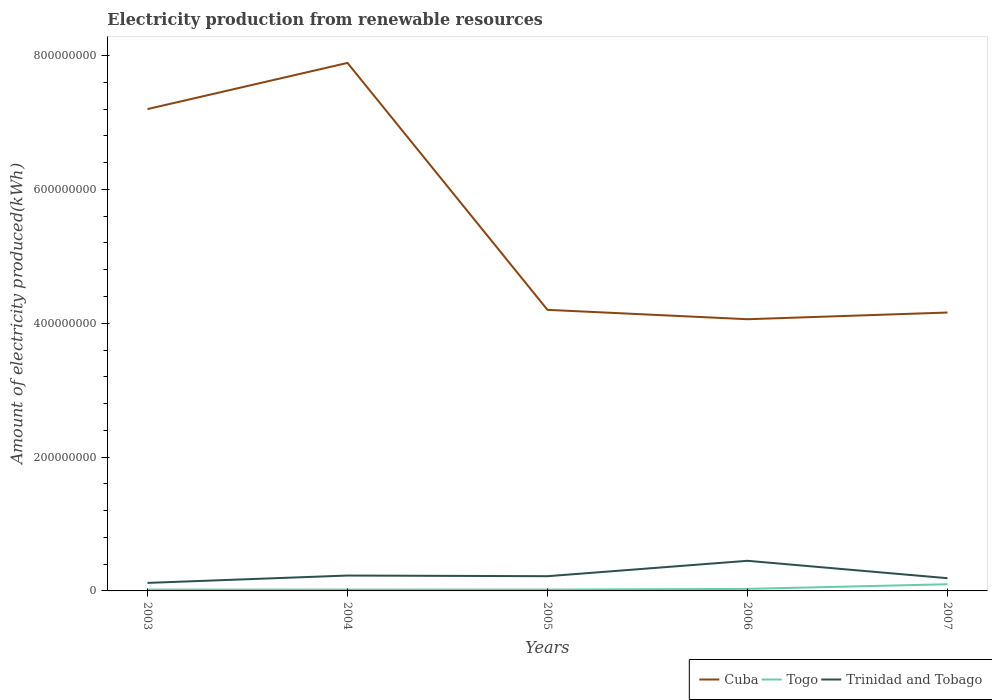How many different coloured lines are there?
Your answer should be very brief. 3. Is the number of lines equal to the number of legend labels?
Your answer should be very brief. Yes. Across all years, what is the maximum amount of electricity produced in Togo?
Give a very brief answer. 2.00e+06. In which year was the amount of electricity produced in Togo maximum?
Offer a very short reply. 2003. What is the total amount of electricity produced in Trinidad and Tobago in the graph?
Offer a very short reply. -3.30e+07. What is the difference between the highest and the second highest amount of electricity produced in Trinidad and Tobago?
Ensure brevity in your answer.  3.30e+07. What is the difference between the highest and the lowest amount of electricity produced in Togo?
Keep it short and to the point. 1. Is the amount of electricity produced in Cuba strictly greater than the amount of electricity produced in Togo over the years?
Keep it short and to the point. No. Does the graph contain any zero values?
Your response must be concise. No. Does the graph contain grids?
Give a very brief answer. No. Where does the legend appear in the graph?
Your answer should be compact. Bottom right. How many legend labels are there?
Your answer should be very brief. 3. What is the title of the graph?
Ensure brevity in your answer.  Electricity production from renewable resources. What is the label or title of the X-axis?
Your response must be concise. Years. What is the label or title of the Y-axis?
Keep it short and to the point. Amount of electricity produced(kWh). What is the Amount of electricity produced(kWh) of Cuba in 2003?
Keep it short and to the point. 7.20e+08. What is the Amount of electricity produced(kWh) in Togo in 2003?
Your response must be concise. 2.00e+06. What is the Amount of electricity produced(kWh) in Cuba in 2004?
Your answer should be very brief. 7.89e+08. What is the Amount of electricity produced(kWh) of Togo in 2004?
Your answer should be compact. 2.00e+06. What is the Amount of electricity produced(kWh) in Trinidad and Tobago in 2004?
Your answer should be compact. 2.30e+07. What is the Amount of electricity produced(kWh) of Cuba in 2005?
Provide a short and direct response. 4.20e+08. What is the Amount of electricity produced(kWh) of Togo in 2005?
Offer a terse response. 2.00e+06. What is the Amount of electricity produced(kWh) in Trinidad and Tobago in 2005?
Keep it short and to the point. 2.20e+07. What is the Amount of electricity produced(kWh) of Cuba in 2006?
Your response must be concise. 4.06e+08. What is the Amount of electricity produced(kWh) in Trinidad and Tobago in 2006?
Your response must be concise. 4.50e+07. What is the Amount of electricity produced(kWh) in Cuba in 2007?
Provide a succinct answer. 4.16e+08. What is the Amount of electricity produced(kWh) of Togo in 2007?
Offer a terse response. 1.00e+07. What is the Amount of electricity produced(kWh) of Trinidad and Tobago in 2007?
Offer a terse response. 1.90e+07. Across all years, what is the maximum Amount of electricity produced(kWh) in Cuba?
Make the answer very short. 7.89e+08. Across all years, what is the maximum Amount of electricity produced(kWh) of Togo?
Keep it short and to the point. 1.00e+07. Across all years, what is the maximum Amount of electricity produced(kWh) of Trinidad and Tobago?
Your answer should be compact. 4.50e+07. Across all years, what is the minimum Amount of electricity produced(kWh) in Cuba?
Your answer should be compact. 4.06e+08. Across all years, what is the minimum Amount of electricity produced(kWh) in Trinidad and Tobago?
Offer a very short reply. 1.20e+07. What is the total Amount of electricity produced(kWh) of Cuba in the graph?
Ensure brevity in your answer.  2.75e+09. What is the total Amount of electricity produced(kWh) in Togo in the graph?
Give a very brief answer. 1.90e+07. What is the total Amount of electricity produced(kWh) of Trinidad and Tobago in the graph?
Ensure brevity in your answer.  1.21e+08. What is the difference between the Amount of electricity produced(kWh) in Cuba in 2003 and that in 2004?
Your response must be concise. -6.90e+07. What is the difference between the Amount of electricity produced(kWh) of Trinidad and Tobago in 2003 and that in 2004?
Provide a short and direct response. -1.10e+07. What is the difference between the Amount of electricity produced(kWh) in Cuba in 2003 and that in 2005?
Your response must be concise. 3.00e+08. What is the difference between the Amount of electricity produced(kWh) of Trinidad and Tobago in 2003 and that in 2005?
Offer a very short reply. -1.00e+07. What is the difference between the Amount of electricity produced(kWh) in Cuba in 2003 and that in 2006?
Give a very brief answer. 3.14e+08. What is the difference between the Amount of electricity produced(kWh) in Trinidad and Tobago in 2003 and that in 2006?
Keep it short and to the point. -3.30e+07. What is the difference between the Amount of electricity produced(kWh) of Cuba in 2003 and that in 2007?
Offer a very short reply. 3.04e+08. What is the difference between the Amount of electricity produced(kWh) in Togo in 2003 and that in 2007?
Keep it short and to the point. -8.00e+06. What is the difference between the Amount of electricity produced(kWh) in Trinidad and Tobago in 2003 and that in 2007?
Your response must be concise. -7.00e+06. What is the difference between the Amount of electricity produced(kWh) of Cuba in 2004 and that in 2005?
Offer a very short reply. 3.69e+08. What is the difference between the Amount of electricity produced(kWh) in Trinidad and Tobago in 2004 and that in 2005?
Make the answer very short. 1.00e+06. What is the difference between the Amount of electricity produced(kWh) in Cuba in 2004 and that in 2006?
Offer a very short reply. 3.83e+08. What is the difference between the Amount of electricity produced(kWh) of Togo in 2004 and that in 2006?
Keep it short and to the point. -1.00e+06. What is the difference between the Amount of electricity produced(kWh) in Trinidad and Tobago in 2004 and that in 2006?
Make the answer very short. -2.20e+07. What is the difference between the Amount of electricity produced(kWh) of Cuba in 2004 and that in 2007?
Offer a very short reply. 3.73e+08. What is the difference between the Amount of electricity produced(kWh) in Togo in 2004 and that in 2007?
Your answer should be compact. -8.00e+06. What is the difference between the Amount of electricity produced(kWh) of Cuba in 2005 and that in 2006?
Offer a terse response. 1.40e+07. What is the difference between the Amount of electricity produced(kWh) in Togo in 2005 and that in 2006?
Offer a very short reply. -1.00e+06. What is the difference between the Amount of electricity produced(kWh) in Trinidad and Tobago in 2005 and that in 2006?
Give a very brief answer. -2.30e+07. What is the difference between the Amount of electricity produced(kWh) in Cuba in 2005 and that in 2007?
Provide a short and direct response. 4.00e+06. What is the difference between the Amount of electricity produced(kWh) of Togo in 2005 and that in 2007?
Give a very brief answer. -8.00e+06. What is the difference between the Amount of electricity produced(kWh) of Cuba in 2006 and that in 2007?
Offer a very short reply. -1.00e+07. What is the difference between the Amount of electricity produced(kWh) in Togo in 2006 and that in 2007?
Provide a short and direct response. -7.00e+06. What is the difference between the Amount of electricity produced(kWh) in Trinidad and Tobago in 2006 and that in 2007?
Ensure brevity in your answer.  2.60e+07. What is the difference between the Amount of electricity produced(kWh) in Cuba in 2003 and the Amount of electricity produced(kWh) in Togo in 2004?
Provide a succinct answer. 7.18e+08. What is the difference between the Amount of electricity produced(kWh) of Cuba in 2003 and the Amount of electricity produced(kWh) of Trinidad and Tobago in 2004?
Provide a succinct answer. 6.97e+08. What is the difference between the Amount of electricity produced(kWh) in Togo in 2003 and the Amount of electricity produced(kWh) in Trinidad and Tobago in 2004?
Provide a short and direct response. -2.10e+07. What is the difference between the Amount of electricity produced(kWh) in Cuba in 2003 and the Amount of electricity produced(kWh) in Togo in 2005?
Offer a terse response. 7.18e+08. What is the difference between the Amount of electricity produced(kWh) in Cuba in 2003 and the Amount of electricity produced(kWh) in Trinidad and Tobago in 2005?
Your answer should be very brief. 6.98e+08. What is the difference between the Amount of electricity produced(kWh) in Togo in 2003 and the Amount of electricity produced(kWh) in Trinidad and Tobago in 2005?
Ensure brevity in your answer.  -2.00e+07. What is the difference between the Amount of electricity produced(kWh) of Cuba in 2003 and the Amount of electricity produced(kWh) of Togo in 2006?
Provide a succinct answer. 7.17e+08. What is the difference between the Amount of electricity produced(kWh) in Cuba in 2003 and the Amount of electricity produced(kWh) in Trinidad and Tobago in 2006?
Your answer should be very brief. 6.75e+08. What is the difference between the Amount of electricity produced(kWh) in Togo in 2003 and the Amount of electricity produced(kWh) in Trinidad and Tobago in 2006?
Provide a short and direct response. -4.30e+07. What is the difference between the Amount of electricity produced(kWh) of Cuba in 2003 and the Amount of electricity produced(kWh) of Togo in 2007?
Make the answer very short. 7.10e+08. What is the difference between the Amount of electricity produced(kWh) in Cuba in 2003 and the Amount of electricity produced(kWh) in Trinidad and Tobago in 2007?
Offer a terse response. 7.01e+08. What is the difference between the Amount of electricity produced(kWh) in Togo in 2003 and the Amount of electricity produced(kWh) in Trinidad and Tobago in 2007?
Offer a very short reply. -1.70e+07. What is the difference between the Amount of electricity produced(kWh) in Cuba in 2004 and the Amount of electricity produced(kWh) in Togo in 2005?
Offer a very short reply. 7.87e+08. What is the difference between the Amount of electricity produced(kWh) in Cuba in 2004 and the Amount of electricity produced(kWh) in Trinidad and Tobago in 2005?
Give a very brief answer. 7.67e+08. What is the difference between the Amount of electricity produced(kWh) of Togo in 2004 and the Amount of electricity produced(kWh) of Trinidad and Tobago in 2005?
Your answer should be compact. -2.00e+07. What is the difference between the Amount of electricity produced(kWh) of Cuba in 2004 and the Amount of electricity produced(kWh) of Togo in 2006?
Your answer should be compact. 7.86e+08. What is the difference between the Amount of electricity produced(kWh) in Cuba in 2004 and the Amount of electricity produced(kWh) in Trinidad and Tobago in 2006?
Your answer should be very brief. 7.44e+08. What is the difference between the Amount of electricity produced(kWh) of Togo in 2004 and the Amount of electricity produced(kWh) of Trinidad and Tobago in 2006?
Provide a succinct answer. -4.30e+07. What is the difference between the Amount of electricity produced(kWh) in Cuba in 2004 and the Amount of electricity produced(kWh) in Togo in 2007?
Give a very brief answer. 7.79e+08. What is the difference between the Amount of electricity produced(kWh) in Cuba in 2004 and the Amount of electricity produced(kWh) in Trinidad and Tobago in 2007?
Offer a terse response. 7.70e+08. What is the difference between the Amount of electricity produced(kWh) of Togo in 2004 and the Amount of electricity produced(kWh) of Trinidad and Tobago in 2007?
Give a very brief answer. -1.70e+07. What is the difference between the Amount of electricity produced(kWh) of Cuba in 2005 and the Amount of electricity produced(kWh) of Togo in 2006?
Your answer should be very brief. 4.17e+08. What is the difference between the Amount of electricity produced(kWh) in Cuba in 2005 and the Amount of electricity produced(kWh) in Trinidad and Tobago in 2006?
Offer a very short reply. 3.75e+08. What is the difference between the Amount of electricity produced(kWh) of Togo in 2005 and the Amount of electricity produced(kWh) of Trinidad and Tobago in 2006?
Provide a short and direct response. -4.30e+07. What is the difference between the Amount of electricity produced(kWh) of Cuba in 2005 and the Amount of electricity produced(kWh) of Togo in 2007?
Your answer should be very brief. 4.10e+08. What is the difference between the Amount of electricity produced(kWh) of Cuba in 2005 and the Amount of electricity produced(kWh) of Trinidad and Tobago in 2007?
Your answer should be very brief. 4.01e+08. What is the difference between the Amount of electricity produced(kWh) in Togo in 2005 and the Amount of electricity produced(kWh) in Trinidad and Tobago in 2007?
Provide a succinct answer. -1.70e+07. What is the difference between the Amount of electricity produced(kWh) of Cuba in 2006 and the Amount of electricity produced(kWh) of Togo in 2007?
Your answer should be compact. 3.96e+08. What is the difference between the Amount of electricity produced(kWh) of Cuba in 2006 and the Amount of electricity produced(kWh) of Trinidad and Tobago in 2007?
Make the answer very short. 3.87e+08. What is the difference between the Amount of electricity produced(kWh) in Togo in 2006 and the Amount of electricity produced(kWh) in Trinidad and Tobago in 2007?
Make the answer very short. -1.60e+07. What is the average Amount of electricity produced(kWh) of Cuba per year?
Offer a very short reply. 5.50e+08. What is the average Amount of electricity produced(kWh) in Togo per year?
Give a very brief answer. 3.80e+06. What is the average Amount of electricity produced(kWh) in Trinidad and Tobago per year?
Your response must be concise. 2.42e+07. In the year 2003, what is the difference between the Amount of electricity produced(kWh) of Cuba and Amount of electricity produced(kWh) of Togo?
Ensure brevity in your answer.  7.18e+08. In the year 2003, what is the difference between the Amount of electricity produced(kWh) of Cuba and Amount of electricity produced(kWh) of Trinidad and Tobago?
Give a very brief answer. 7.08e+08. In the year 2003, what is the difference between the Amount of electricity produced(kWh) of Togo and Amount of electricity produced(kWh) of Trinidad and Tobago?
Make the answer very short. -1.00e+07. In the year 2004, what is the difference between the Amount of electricity produced(kWh) in Cuba and Amount of electricity produced(kWh) in Togo?
Ensure brevity in your answer.  7.87e+08. In the year 2004, what is the difference between the Amount of electricity produced(kWh) of Cuba and Amount of electricity produced(kWh) of Trinidad and Tobago?
Your answer should be compact. 7.66e+08. In the year 2004, what is the difference between the Amount of electricity produced(kWh) in Togo and Amount of electricity produced(kWh) in Trinidad and Tobago?
Ensure brevity in your answer.  -2.10e+07. In the year 2005, what is the difference between the Amount of electricity produced(kWh) in Cuba and Amount of electricity produced(kWh) in Togo?
Ensure brevity in your answer.  4.18e+08. In the year 2005, what is the difference between the Amount of electricity produced(kWh) in Cuba and Amount of electricity produced(kWh) in Trinidad and Tobago?
Make the answer very short. 3.98e+08. In the year 2005, what is the difference between the Amount of electricity produced(kWh) in Togo and Amount of electricity produced(kWh) in Trinidad and Tobago?
Offer a very short reply. -2.00e+07. In the year 2006, what is the difference between the Amount of electricity produced(kWh) in Cuba and Amount of electricity produced(kWh) in Togo?
Keep it short and to the point. 4.03e+08. In the year 2006, what is the difference between the Amount of electricity produced(kWh) of Cuba and Amount of electricity produced(kWh) of Trinidad and Tobago?
Give a very brief answer. 3.61e+08. In the year 2006, what is the difference between the Amount of electricity produced(kWh) in Togo and Amount of electricity produced(kWh) in Trinidad and Tobago?
Ensure brevity in your answer.  -4.20e+07. In the year 2007, what is the difference between the Amount of electricity produced(kWh) in Cuba and Amount of electricity produced(kWh) in Togo?
Offer a terse response. 4.06e+08. In the year 2007, what is the difference between the Amount of electricity produced(kWh) of Cuba and Amount of electricity produced(kWh) of Trinidad and Tobago?
Provide a short and direct response. 3.97e+08. In the year 2007, what is the difference between the Amount of electricity produced(kWh) in Togo and Amount of electricity produced(kWh) in Trinidad and Tobago?
Provide a succinct answer. -9.00e+06. What is the ratio of the Amount of electricity produced(kWh) in Cuba in 2003 to that in 2004?
Give a very brief answer. 0.91. What is the ratio of the Amount of electricity produced(kWh) of Togo in 2003 to that in 2004?
Provide a short and direct response. 1. What is the ratio of the Amount of electricity produced(kWh) in Trinidad and Tobago in 2003 to that in 2004?
Offer a terse response. 0.52. What is the ratio of the Amount of electricity produced(kWh) in Cuba in 2003 to that in 2005?
Offer a terse response. 1.71. What is the ratio of the Amount of electricity produced(kWh) in Togo in 2003 to that in 2005?
Provide a short and direct response. 1. What is the ratio of the Amount of electricity produced(kWh) of Trinidad and Tobago in 2003 to that in 2005?
Make the answer very short. 0.55. What is the ratio of the Amount of electricity produced(kWh) of Cuba in 2003 to that in 2006?
Your response must be concise. 1.77. What is the ratio of the Amount of electricity produced(kWh) of Trinidad and Tobago in 2003 to that in 2006?
Your response must be concise. 0.27. What is the ratio of the Amount of electricity produced(kWh) of Cuba in 2003 to that in 2007?
Offer a terse response. 1.73. What is the ratio of the Amount of electricity produced(kWh) in Togo in 2003 to that in 2007?
Provide a succinct answer. 0.2. What is the ratio of the Amount of electricity produced(kWh) of Trinidad and Tobago in 2003 to that in 2007?
Your response must be concise. 0.63. What is the ratio of the Amount of electricity produced(kWh) in Cuba in 2004 to that in 2005?
Your answer should be compact. 1.88. What is the ratio of the Amount of electricity produced(kWh) in Togo in 2004 to that in 2005?
Make the answer very short. 1. What is the ratio of the Amount of electricity produced(kWh) in Trinidad and Tobago in 2004 to that in 2005?
Keep it short and to the point. 1.05. What is the ratio of the Amount of electricity produced(kWh) in Cuba in 2004 to that in 2006?
Provide a short and direct response. 1.94. What is the ratio of the Amount of electricity produced(kWh) in Trinidad and Tobago in 2004 to that in 2006?
Give a very brief answer. 0.51. What is the ratio of the Amount of electricity produced(kWh) of Cuba in 2004 to that in 2007?
Keep it short and to the point. 1.9. What is the ratio of the Amount of electricity produced(kWh) in Togo in 2004 to that in 2007?
Provide a succinct answer. 0.2. What is the ratio of the Amount of electricity produced(kWh) of Trinidad and Tobago in 2004 to that in 2007?
Give a very brief answer. 1.21. What is the ratio of the Amount of electricity produced(kWh) of Cuba in 2005 to that in 2006?
Offer a terse response. 1.03. What is the ratio of the Amount of electricity produced(kWh) of Trinidad and Tobago in 2005 to that in 2006?
Ensure brevity in your answer.  0.49. What is the ratio of the Amount of electricity produced(kWh) in Cuba in 2005 to that in 2007?
Provide a short and direct response. 1.01. What is the ratio of the Amount of electricity produced(kWh) in Trinidad and Tobago in 2005 to that in 2007?
Your answer should be very brief. 1.16. What is the ratio of the Amount of electricity produced(kWh) in Togo in 2006 to that in 2007?
Your answer should be compact. 0.3. What is the ratio of the Amount of electricity produced(kWh) of Trinidad and Tobago in 2006 to that in 2007?
Offer a terse response. 2.37. What is the difference between the highest and the second highest Amount of electricity produced(kWh) of Cuba?
Your answer should be very brief. 6.90e+07. What is the difference between the highest and the second highest Amount of electricity produced(kWh) of Togo?
Make the answer very short. 7.00e+06. What is the difference between the highest and the second highest Amount of electricity produced(kWh) in Trinidad and Tobago?
Keep it short and to the point. 2.20e+07. What is the difference between the highest and the lowest Amount of electricity produced(kWh) in Cuba?
Provide a short and direct response. 3.83e+08. What is the difference between the highest and the lowest Amount of electricity produced(kWh) in Trinidad and Tobago?
Your answer should be very brief. 3.30e+07. 